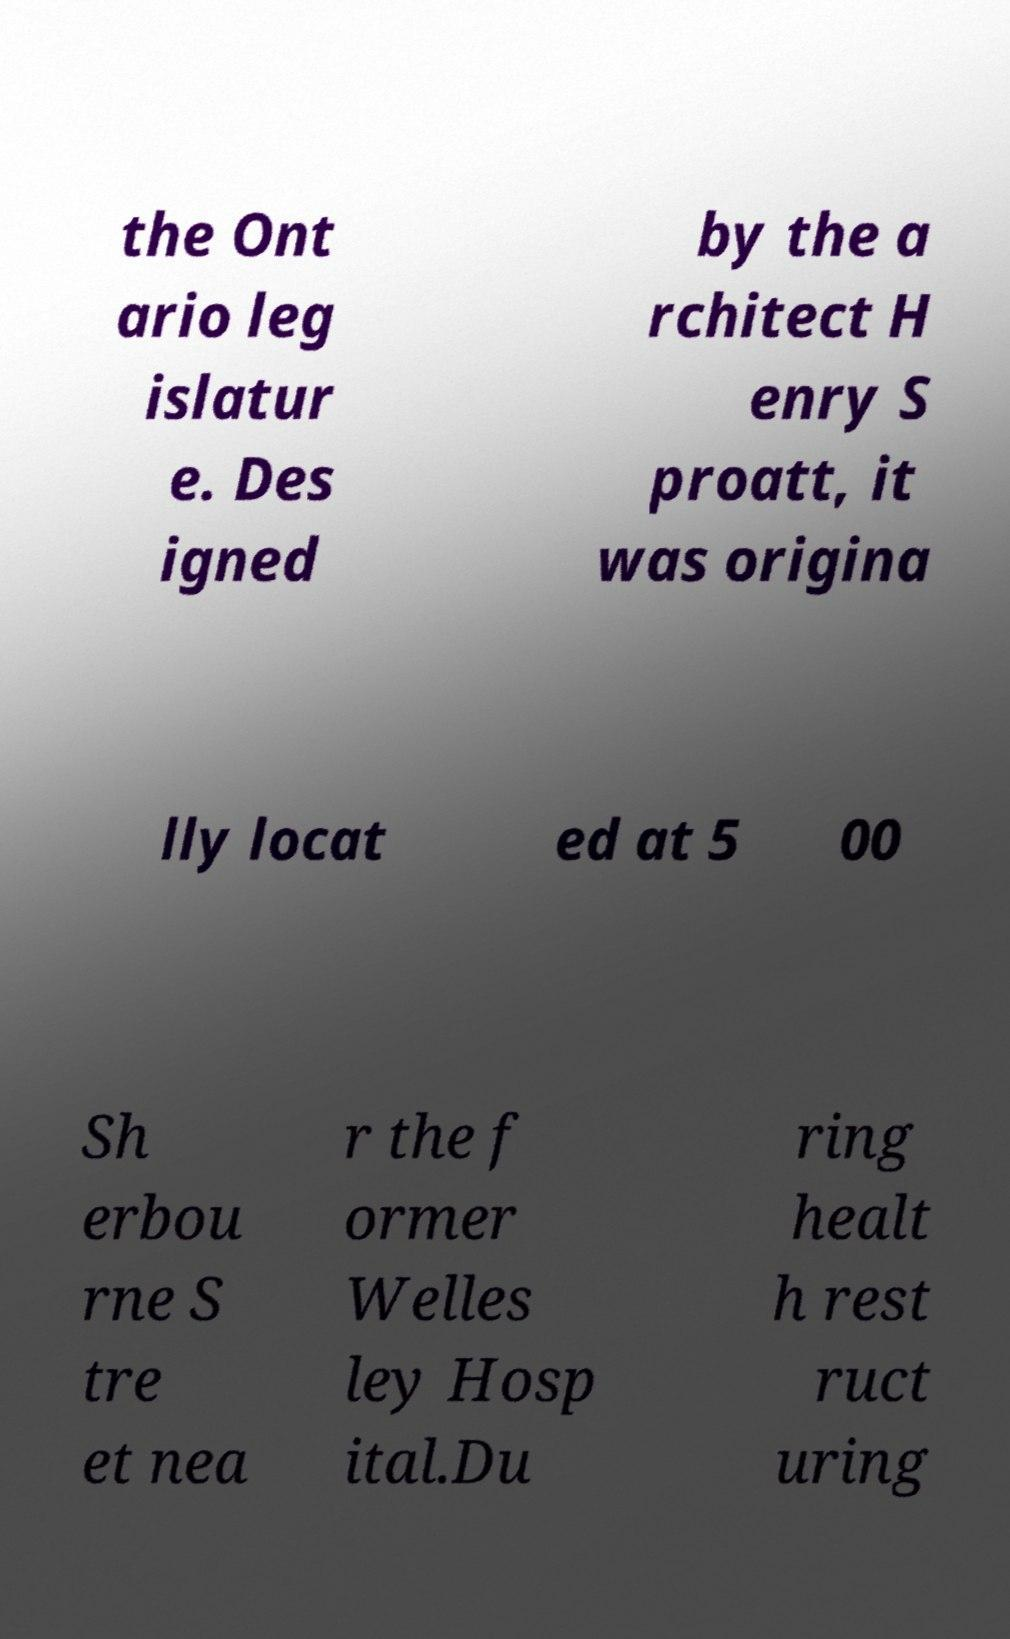Please identify and transcribe the text found in this image. the Ont ario leg islatur e. Des igned by the a rchitect H enry S proatt, it was origina lly locat ed at 5 00 Sh erbou rne S tre et nea r the f ormer Welles ley Hosp ital.Du ring healt h rest ruct uring 